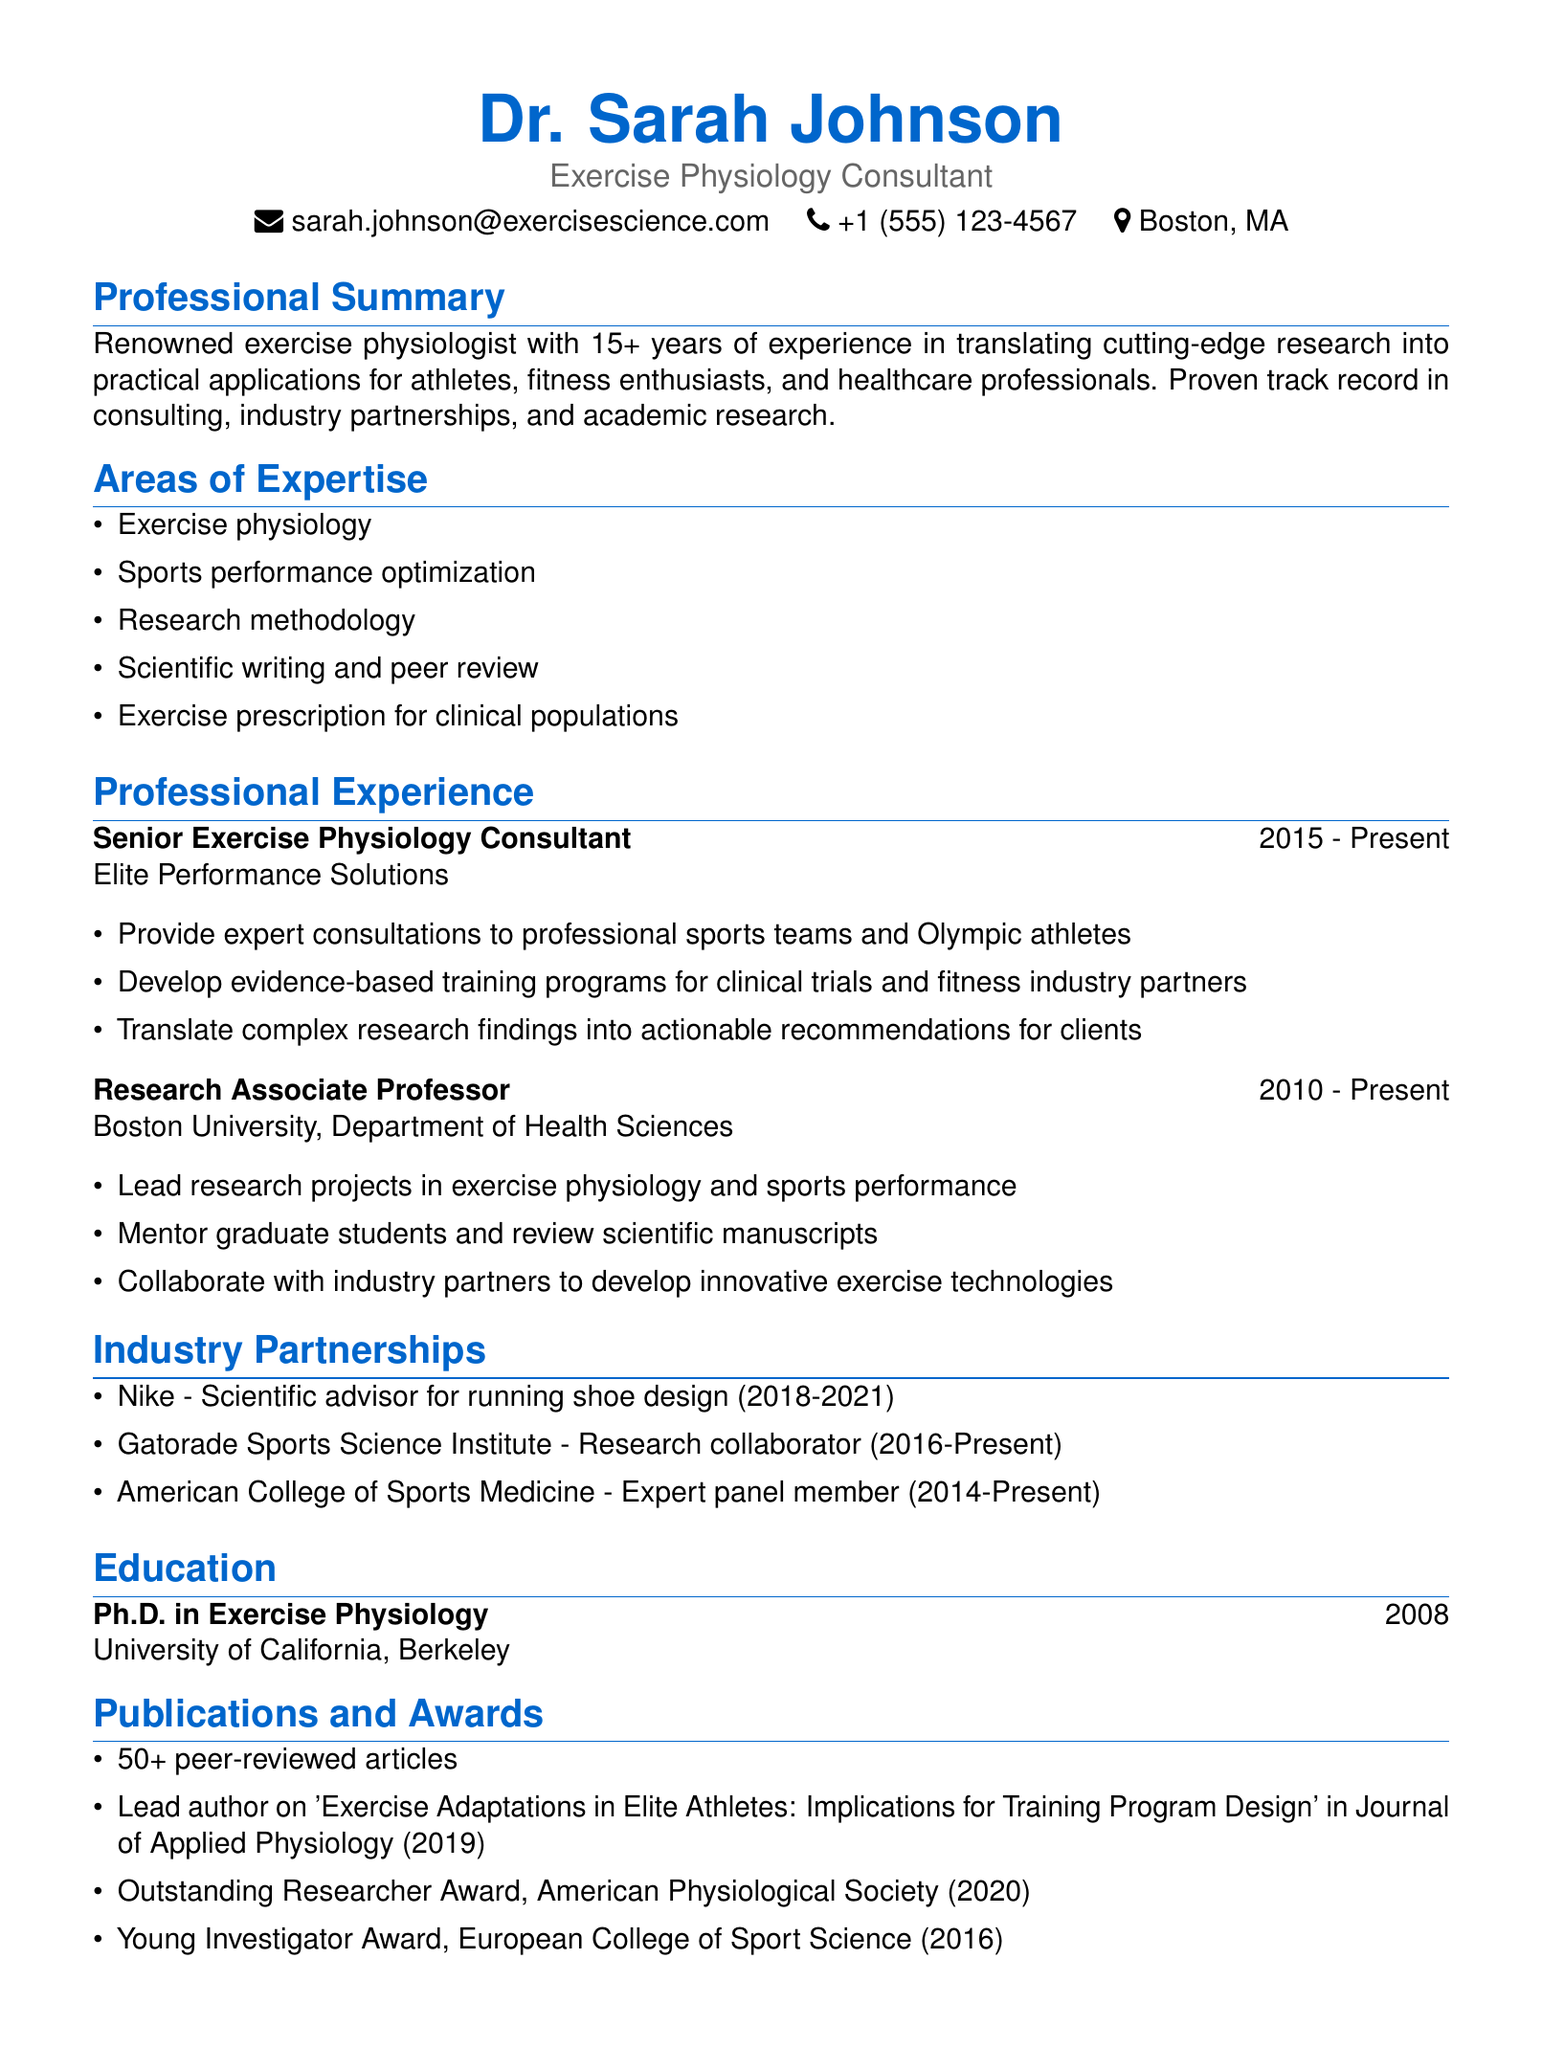What is the name of the consultant? The name of the consultant is provided at the top of the document.
Answer: Dr. Sarah Johnson What is Dr. Johnson's current position? The document lists her current role prominently in the professional title section.
Answer: Exercise Physiology Consultant How many years of experience does Dr. Johnson have? The professional summary states her years of experience clearly.
Answer: 15+ Which university did Dr. Johnson obtain her Ph.D. from? The education section specifies the institution where she earned her degree.
Answer: University of California, Berkeley What notable award did Dr. Johnson receive in 2020? The awards section highlights specific achievements and recognitions she has received.
Answer: Outstanding Researcher Award What type of organizations has Dr. Johnson partnered with? The industry partnerships section provides examples of organizations she collaborates with.
Answer: Nike, Gatorade Sports Science Institute, American College of Sports Medicine What is one of Dr. Johnson's areas of expertise? The specific areas of expertise are listed in a bullet format.
Answer: Exercise physiology What is a key highlight of Dr. Johnson's publications? The publications section details her contribution to academic literature.
Answer: Lead author on 'Exercise Adaptations in Elite Athletes: Implications for Training Program Design' In what year did Dr. Johnson start her role at Elite Performance Solutions? The experience section provides the start year for this role.
Answer: 2015 Which document type is this? This document is structured specifically for professional highlight purposes.
Answer: Resume 